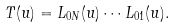Convert formula to latex. <formula><loc_0><loc_0><loc_500><loc_500>T ( u ) = L _ { 0 N } ( u ) \cdots L _ { 0 1 } ( u ) .</formula> 